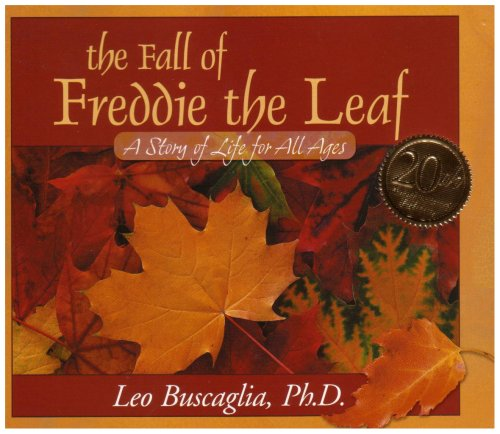Is this book related to Self-Help? Yes, this book is intimately related to Self-Help as it delves into the introspection of life's meaning and the acceptance of life's inevitable cycle, offering comfort and understanding about human experiences. 